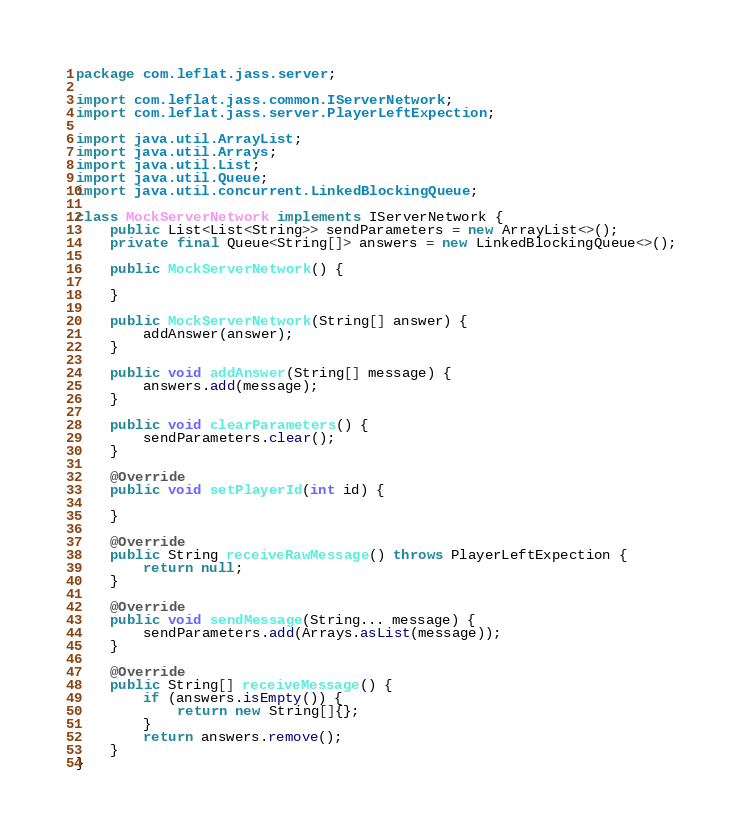<code> <loc_0><loc_0><loc_500><loc_500><_Java_>package com.leflat.jass.server;

import com.leflat.jass.common.IServerNetwork;
import com.leflat.jass.server.PlayerLeftExpection;

import java.util.ArrayList;
import java.util.Arrays;
import java.util.List;
import java.util.Queue;
import java.util.concurrent.LinkedBlockingQueue;

class MockServerNetwork implements IServerNetwork {
    public List<List<String>> sendParameters = new ArrayList<>();
    private final Queue<String[]> answers = new LinkedBlockingQueue<>();

    public MockServerNetwork() {

    }

    public MockServerNetwork(String[] answer) {
        addAnswer(answer);
    }

    public void addAnswer(String[] message) {
        answers.add(message);
    }

    public void clearParameters() {
        sendParameters.clear();
    }

    @Override
    public void setPlayerId(int id) {

    }

    @Override
    public String receiveRawMessage() throws PlayerLeftExpection {
        return null;
    }

    @Override
    public void sendMessage(String... message) {
        sendParameters.add(Arrays.asList(message));
    }

    @Override
    public String[] receiveMessage() {
        if (answers.isEmpty()) {
            return new String[]{};
        }
        return answers.remove();
    }
}
</code> 